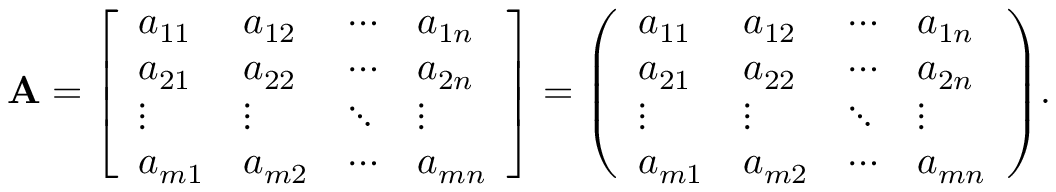Convert formula to latex. <formula><loc_0><loc_0><loc_500><loc_500>A = { \left [ \begin{array} { l l l l } { a _ { 1 1 } } & { a _ { 1 2 } } & { \cdots } & { a _ { 1 n } } \\ { a _ { 2 1 } } & { a _ { 2 2 } } & { \cdots } & { a _ { 2 n } } \\ { \vdots } & { \vdots } & { \ddots } & { \vdots } \\ { a _ { m 1 } } & { a _ { m 2 } } & { \cdots } & { a _ { m n } } \end{array} \right ] } = { \left ( \begin{array} { l l l l } { a _ { 1 1 } } & { a _ { 1 2 } } & { \cdots } & { a _ { 1 n } } \\ { a _ { 2 1 } } & { a _ { 2 2 } } & { \cdots } & { a _ { 2 n } } \\ { \vdots } & { \vdots } & { \ddots } & { \vdots } \\ { a _ { m 1 } } & { a _ { m 2 } } & { \cdots } & { a _ { m n } } \end{array} \right ) } .</formula> 